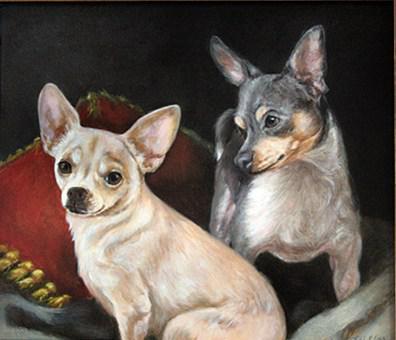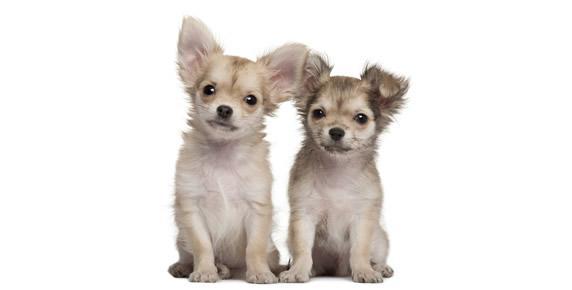The first image is the image on the left, the second image is the image on the right. Given the left and right images, does the statement "In one image, two furry chihuahuas are posed sitting upright side-by-side, facing the camera." hold true? Answer yes or no. Yes. The first image is the image on the left, the second image is the image on the right. Evaluate the accuracy of this statement regarding the images: "There are two dogs standing in the grass in each of the images.". Is it true? Answer yes or no. No. 